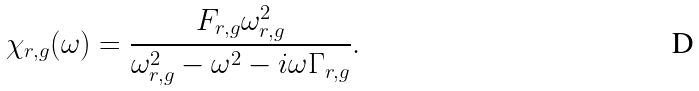<formula> <loc_0><loc_0><loc_500><loc_500>\chi _ { r , g } ( \omega ) = \frac { F _ { r , g } \omega _ { r , g } ^ { 2 } } { \omega _ { r , g } ^ { 2 } - \omega ^ { 2 } - i \omega \Gamma _ { r , g } } .</formula> 